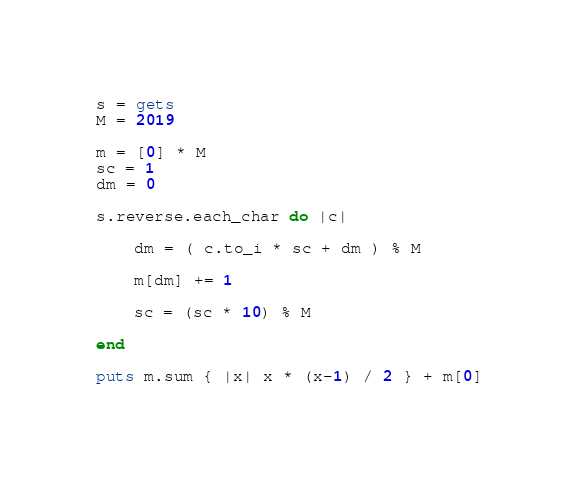<code> <loc_0><loc_0><loc_500><loc_500><_Ruby_>s = gets
M = 2019

m = [0] * M
sc = 1
dm = 0

s.reverse.each_char do |c|
    
    dm = ( c.to_i * sc + dm ) % M
    
    m[dm] += 1
    
    sc = (sc * 10) % M

end

puts m.sum { |x| x * (x-1) / 2 } + m[0]</code> 